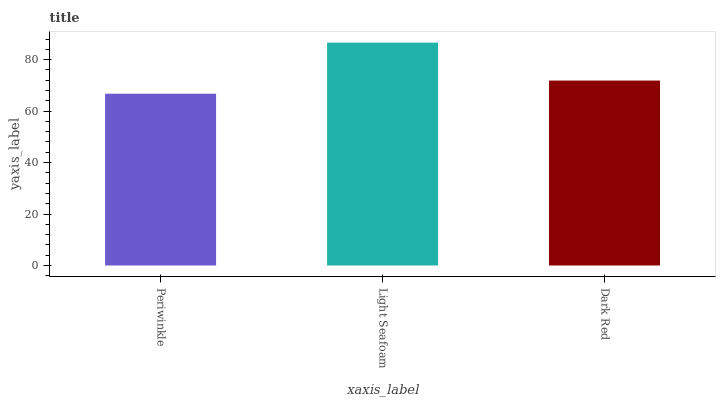Is Periwinkle the minimum?
Answer yes or no. Yes. Is Light Seafoam the maximum?
Answer yes or no. Yes. Is Dark Red the minimum?
Answer yes or no. No. Is Dark Red the maximum?
Answer yes or no. No. Is Light Seafoam greater than Dark Red?
Answer yes or no. Yes. Is Dark Red less than Light Seafoam?
Answer yes or no. Yes. Is Dark Red greater than Light Seafoam?
Answer yes or no. No. Is Light Seafoam less than Dark Red?
Answer yes or no. No. Is Dark Red the high median?
Answer yes or no. Yes. Is Dark Red the low median?
Answer yes or no. Yes. Is Periwinkle the high median?
Answer yes or no. No. Is Periwinkle the low median?
Answer yes or no. No. 